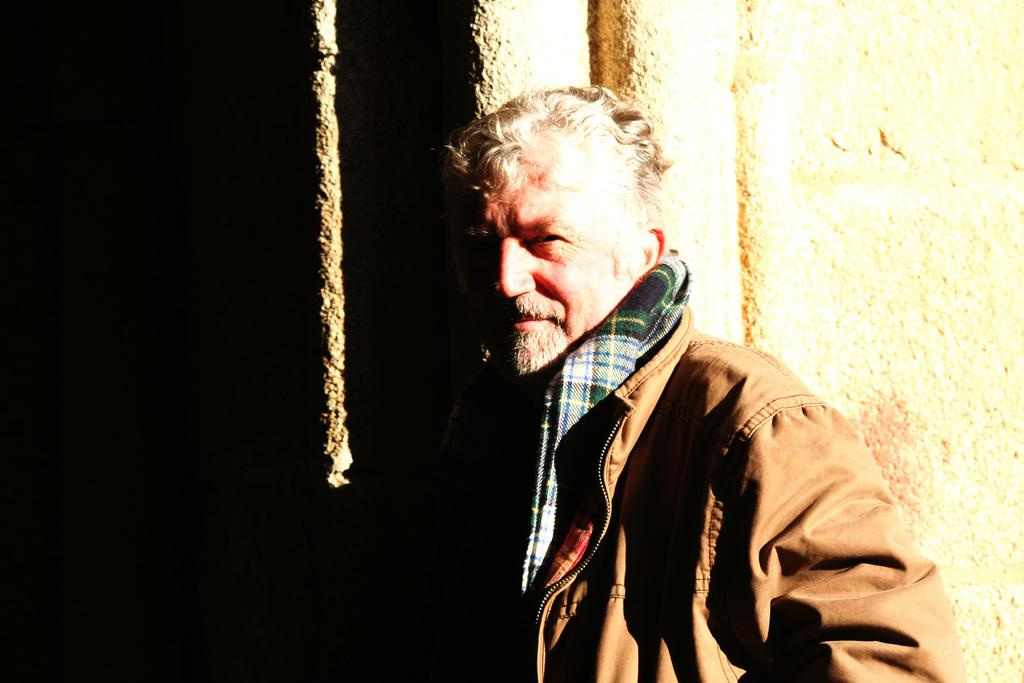What is present in the image? There is a person in the image. Can you describe the person's attire? The person is wearing clothes. What can be seen in the background of the image? There is a wall in the image. How does the needle contribute to the image? There is no needle present in the image. 